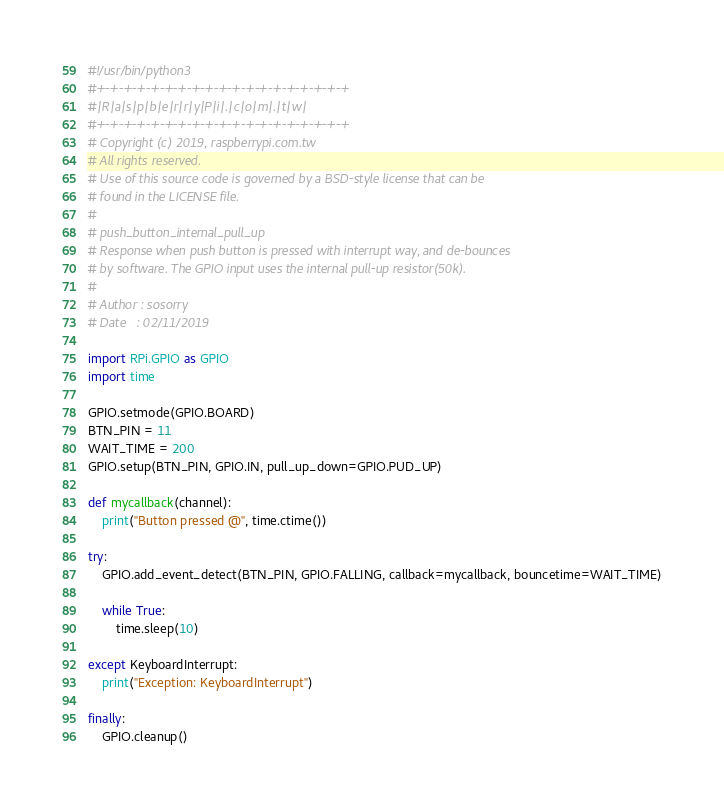<code> <loc_0><loc_0><loc_500><loc_500><_Python_>#!/usr/bin/python3
#+-+-+-+-+-+-+-+-+-+-+-+-+-+-+-+-+-+-+
#|R|a|s|p|b|e|r|r|y|P|i|.|c|o|m|.|t|w|
#+-+-+-+-+-+-+-+-+-+-+-+-+-+-+-+-+-+-+
# Copyright (c) 2019, raspberrypi.com.tw
# All rights reserved.
# Use of this source code is governed by a BSD-style license that can be
# found in the LICENSE file.
#
# push_button_internal_pull_up
# Response when push button is pressed with interrupt way, and de-bounces 
# by software. The GPIO input uses the internal pull-up resistor(50k).
#
# Author : sosorry
# Date   : 02/11/2019

import RPi.GPIO as GPIO                 
import time

GPIO.setmode(GPIO.BOARD)                
BTN_PIN = 11
WAIT_TIME = 200
GPIO.setup(BTN_PIN, GPIO.IN, pull_up_down=GPIO.PUD_UP)

def mycallback(channel):
    print("Button pressed @", time.ctime())

try:
    GPIO.add_event_detect(BTN_PIN, GPIO.FALLING, callback=mycallback, bouncetime=WAIT_TIME)

    while True:
        time.sleep(10)

except KeyboardInterrupt:
    print("Exception: KeyboardInterrupt")

finally:
    GPIO.cleanup()          
</code> 